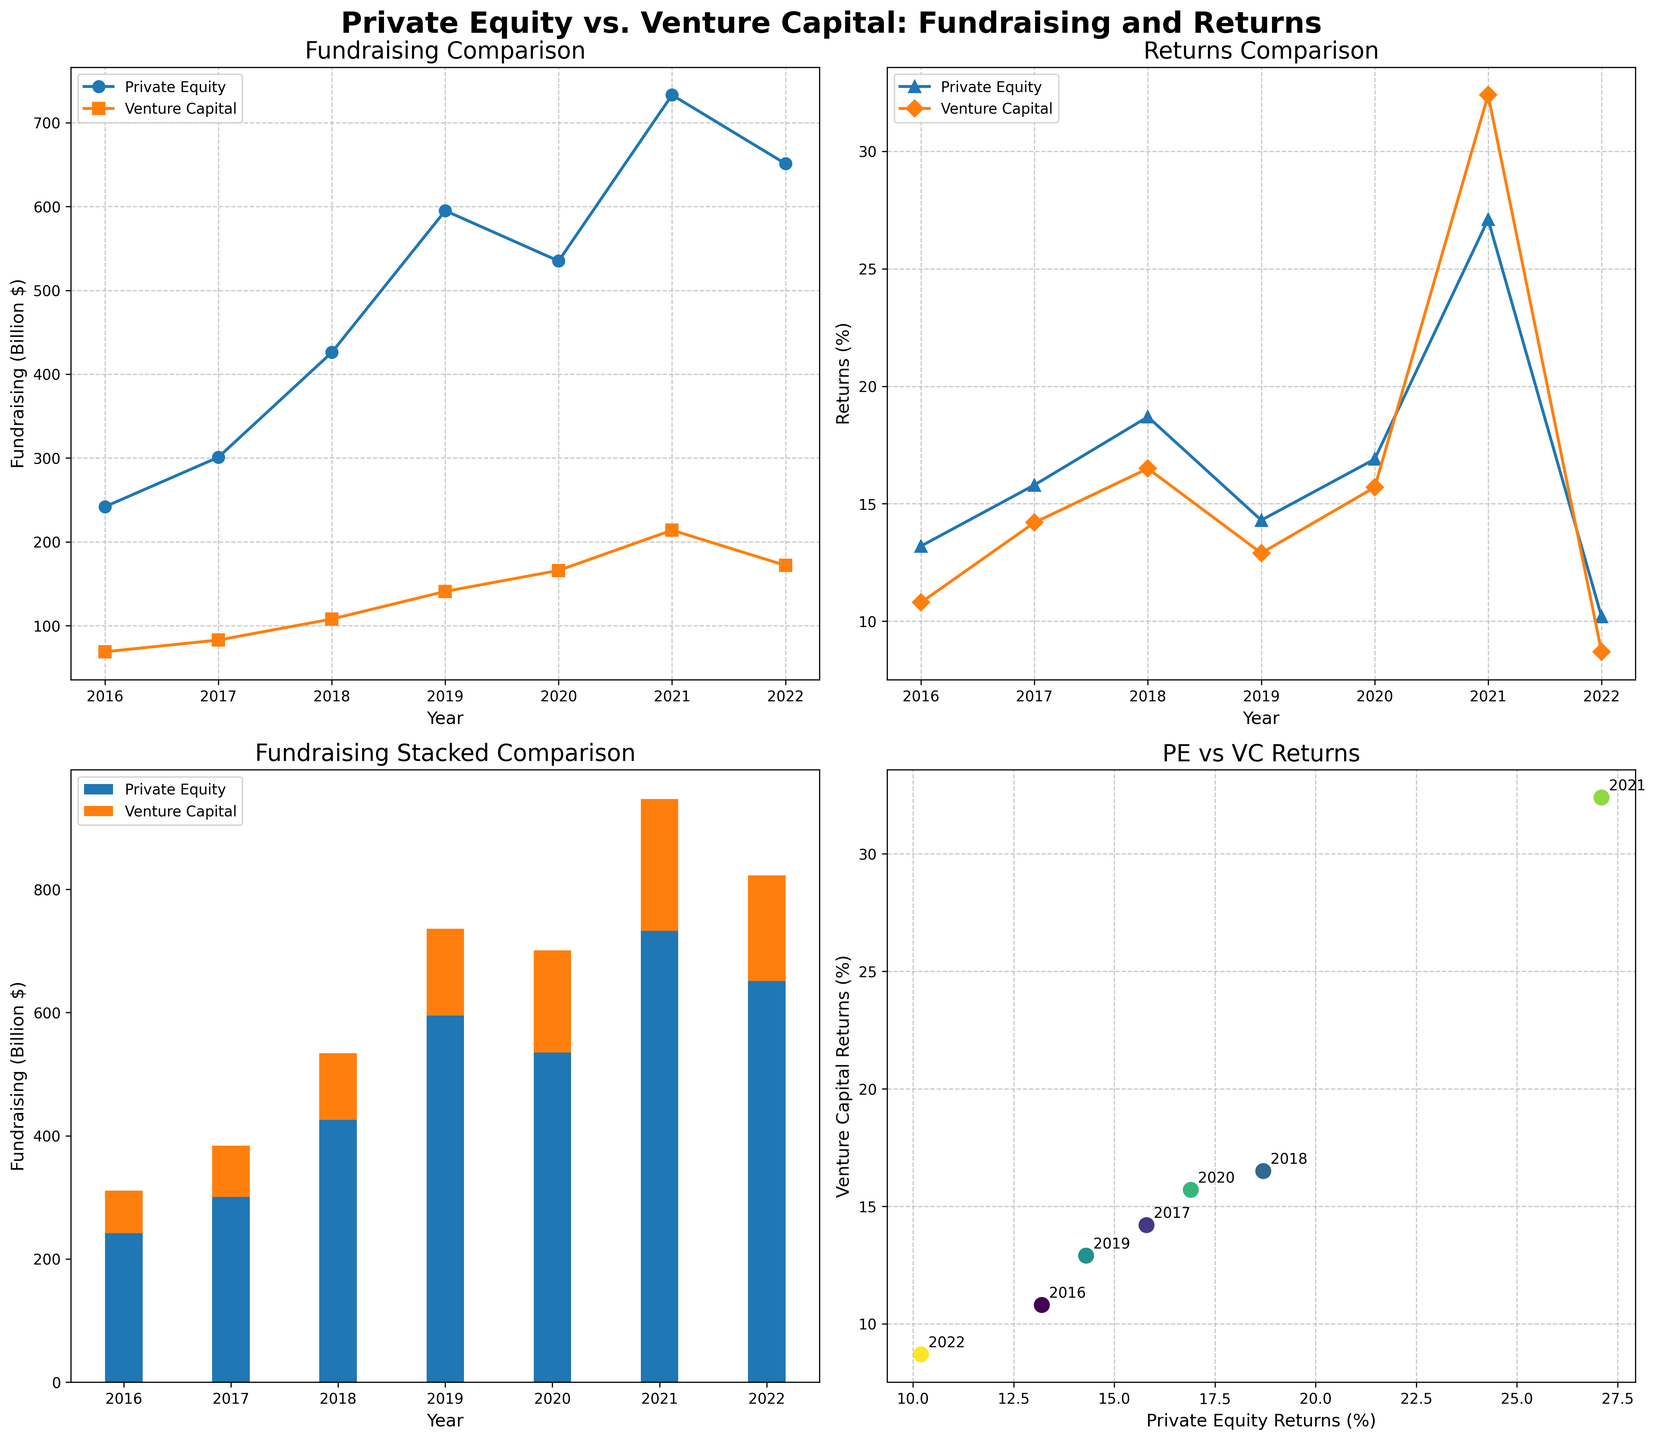What is the title of the figure? The title of the figure is displayed at the top in a larger, bold font. It reads 'Private Equity vs. Venture Capital: Fundraising and Returns'.
Answer: Private Equity vs. Venture Capital: Fundraising and Returns How much was raised by Private Equity in 2018? Look at the first subplot in the grid labeled 'Fundraising Comparison' and find the value for Private Equity in 2018. It appears to be around 426 billion dollars.
Answer: 426 billion dollars In which year did Venture Capital returns peak, and what was the value? In the second subplot labeled 'Returns Comparison', note the peak value for Venture Capital returns; this occurs around the year 2021 with a value of 32.4%.
Answer: 2021, 32.4% Which year shows the largest difference in fundraising between Private Equity and Venture Capital? Compare the difference in fundraising amounts in the 'Fundraising Comparison’ subplot. The largest difference is noticeable in 2021, where Private Equity raised significantly more funds compared to Venture Capital.
Answer: 2021 What are the axes labels of the Returns Scatter Plot? In the scatter plot subplot labeled 'PE vs VC Returns', the x-axis is labeled 'Private Equity Returns (%)' and the y-axis is labeled 'Venture Capital Returns (%)'.
Answer: Private Equity Returns (%) and Venture Capital Returns (%) What is the trend of Private Equity fundraising from 2016 to 2022? Review the first subplot labeled 'Fundraising Comparison'. Private Equity fundraising initially increases substantially peaking in 2021 and then slightly drops in 2022.
Answer: Increasing trend with a peak in 2021 and a drop in 2022 How did Venture Capital returns change from 2021 to 2022? Check the 'Returns Comparison' subplot for Venture Capital returns between 2021 and 2022. The return percentage decreased from 32.4% in 2021 to 8.7% in 2022.
Answer: Decreased Which funding type had a higher return in 2020, and by how much? Look at the returns in 2020 in the 'Returns Comparison' subplot. Private Equity had a return of 16.9%, while Venture Capital had 15.7%. The difference is 1.2%.
Answer: Private Equity by 1.2% In the fundraising stacked bar chart, what is the total fundraising amount for both types in 2019? Sum the values of Private Equity and Venture Capital listed in the stacked bar chart for 2019. Private Equity is 595 billion dollars, and Venture Capital is 141 billion dollars, making the total 736 billion dollars.
Answer: 736 billion dollars Looking at the scatter plot, which year corresponds to the data point closest to the origin? In the 'PE vs VC Returns' scatter plot, the data point for the year 2022 is closest to the origin, indicating the lowest returns for both Private Equity and Venture Capital.
Answer: 2022 